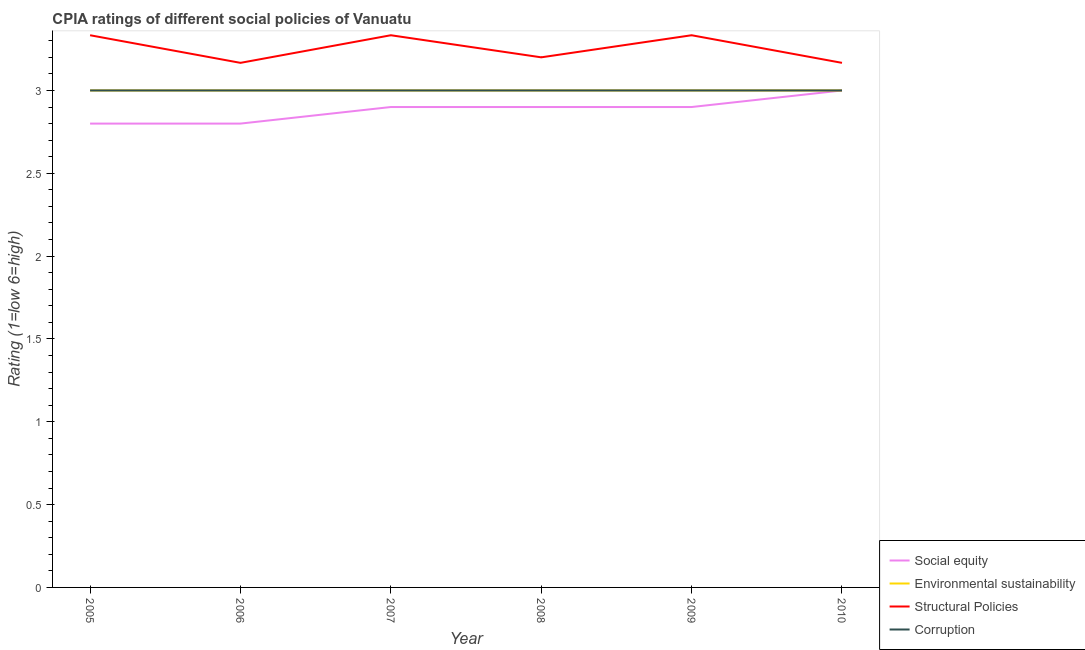Is the number of lines equal to the number of legend labels?
Offer a very short reply. Yes. What is the cpia rating of structural policies in 2010?
Provide a succinct answer. 3.17. Across all years, what is the maximum cpia rating of structural policies?
Your answer should be compact. 3.33. Across all years, what is the minimum cpia rating of corruption?
Your answer should be very brief. 3. In which year was the cpia rating of structural policies minimum?
Keep it short and to the point. 2006. What is the total cpia rating of corruption in the graph?
Offer a terse response. 18. What is the difference between the cpia rating of structural policies in 2008 and that in 2010?
Make the answer very short. 0.03. What is the difference between the cpia rating of social equity in 2009 and the cpia rating of structural policies in 2010?
Provide a succinct answer. -0.27. What is the average cpia rating of social equity per year?
Provide a succinct answer. 2.88. Is the difference between the cpia rating of corruption in 2007 and 2009 greater than the difference between the cpia rating of structural policies in 2007 and 2009?
Offer a terse response. No. What is the difference between the highest and the second highest cpia rating of structural policies?
Your response must be concise. 0. What is the difference between the highest and the lowest cpia rating of corruption?
Offer a terse response. 0. In how many years, is the cpia rating of social equity greater than the average cpia rating of social equity taken over all years?
Ensure brevity in your answer.  4. Is it the case that in every year, the sum of the cpia rating of environmental sustainability and cpia rating of corruption is greater than the sum of cpia rating of structural policies and cpia rating of social equity?
Keep it short and to the point. No. Is the cpia rating of corruption strictly greater than the cpia rating of environmental sustainability over the years?
Offer a very short reply. No. Is the cpia rating of environmental sustainability strictly less than the cpia rating of social equity over the years?
Offer a terse response. No. How many lines are there?
Ensure brevity in your answer.  4. Are the values on the major ticks of Y-axis written in scientific E-notation?
Ensure brevity in your answer.  No. Does the graph contain any zero values?
Make the answer very short. No. Does the graph contain grids?
Offer a very short reply. No. How many legend labels are there?
Keep it short and to the point. 4. How are the legend labels stacked?
Your answer should be very brief. Vertical. What is the title of the graph?
Make the answer very short. CPIA ratings of different social policies of Vanuatu. What is the label or title of the X-axis?
Offer a terse response. Year. What is the label or title of the Y-axis?
Make the answer very short. Rating (1=low 6=high). What is the Rating (1=low 6=high) in Social equity in 2005?
Offer a very short reply. 2.8. What is the Rating (1=low 6=high) of Structural Policies in 2005?
Provide a short and direct response. 3.33. What is the Rating (1=low 6=high) in Social equity in 2006?
Your response must be concise. 2.8. What is the Rating (1=low 6=high) in Environmental sustainability in 2006?
Give a very brief answer. 3. What is the Rating (1=low 6=high) of Structural Policies in 2006?
Ensure brevity in your answer.  3.17. What is the Rating (1=low 6=high) of Corruption in 2006?
Your answer should be very brief. 3. What is the Rating (1=low 6=high) of Environmental sustainability in 2007?
Make the answer very short. 3. What is the Rating (1=low 6=high) in Structural Policies in 2007?
Keep it short and to the point. 3.33. What is the Rating (1=low 6=high) of Corruption in 2007?
Your response must be concise. 3. What is the Rating (1=low 6=high) of Social equity in 2008?
Make the answer very short. 2.9. What is the Rating (1=low 6=high) in Environmental sustainability in 2008?
Your answer should be compact. 3. What is the Rating (1=low 6=high) in Corruption in 2008?
Provide a succinct answer. 3. What is the Rating (1=low 6=high) of Social equity in 2009?
Your answer should be very brief. 2.9. What is the Rating (1=low 6=high) of Environmental sustainability in 2009?
Provide a short and direct response. 3. What is the Rating (1=low 6=high) in Structural Policies in 2009?
Keep it short and to the point. 3.33. What is the Rating (1=low 6=high) of Corruption in 2009?
Ensure brevity in your answer.  3. What is the Rating (1=low 6=high) of Structural Policies in 2010?
Make the answer very short. 3.17. Across all years, what is the maximum Rating (1=low 6=high) of Social equity?
Make the answer very short. 3. Across all years, what is the maximum Rating (1=low 6=high) in Environmental sustainability?
Give a very brief answer. 3. Across all years, what is the maximum Rating (1=low 6=high) of Structural Policies?
Your response must be concise. 3.33. Across all years, what is the minimum Rating (1=low 6=high) of Structural Policies?
Your answer should be compact. 3.17. What is the total Rating (1=low 6=high) in Social equity in the graph?
Your answer should be very brief. 17.3. What is the total Rating (1=low 6=high) of Environmental sustainability in the graph?
Your answer should be very brief. 18. What is the total Rating (1=low 6=high) in Structural Policies in the graph?
Offer a terse response. 19.53. What is the difference between the Rating (1=low 6=high) in Social equity in 2005 and that in 2006?
Keep it short and to the point. 0. What is the difference between the Rating (1=low 6=high) in Environmental sustainability in 2005 and that in 2007?
Offer a terse response. 0. What is the difference between the Rating (1=low 6=high) of Structural Policies in 2005 and that in 2007?
Provide a succinct answer. 0. What is the difference between the Rating (1=low 6=high) of Environmental sustainability in 2005 and that in 2008?
Provide a succinct answer. 0. What is the difference between the Rating (1=low 6=high) of Structural Policies in 2005 and that in 2008?
Your response must be concise. 0.13. What is the difference between the Rating (1=low 6=high) in Environmental sustainability in 2005 and that in 2009?
Give a very brief answer. 0. What is the difference between the Rating (1=low 6=high) in Social equity in 2005 and that in 2010?
Ensure brevity in your answer.  -0.2. What is the difference between the Rating (1=low 6=high) of Environmental sustainability in 2005 and that in 2010?
Make the answer very short. 0. What is the difference between the Rating (1=low 6=high) of Corruption in 2005 and that in 2010?
Your answer should be compact. 0. What is the difference between the Rating (1=low 6=high) in Social equity in 2006 and that in 2008?
Offer a very short reply. -0.1. What is the difference between the Rating (1=low 6=high) in Structural Policies in 2006 and that in 2008?
Keep it short and to the point. -0.03. What is the difference between the Rating (1=low 6=high) of Social equity in 2006 and that in 2009?
Your answer should be compact. -0.1. What is the difference between the Rating (1=low 6=high) of Corruption in 2006 and that in 2009?
Provide a short and direct response. 0. What is the difference between the Rating (1=low 6=high) of Environmental sustainability in 2006 and that in 2010?
Make the answer very short. 0. What is the difference between the Rating (1=low 6=high) of Structural Policies in 2006 and that in 2010?
Offer a terse response. 0. What is the difference between the Rating (1=low 6=high) of Social equity in 2007 and that in 2008?
Ensure brevity in your answer.  0. What is the difference between the Rating (1=low 6=high) of Environmental sustainability in 2007 and that in 2008?
Your answer should be very brief. 0. What is the difference between the Rating (1=low 6=high) of Structural Policies in 2007 and that in 2008?
Provide a succinct answer. 0.13. What is the difference between the Rating (1=low 6=high) of Corruption in 2007 and that in 2008?
Offer a very short reply. 0. What is the difference between the Rating (1=low 6=high) in Social equity in 2007 and that in 2009?
Ensure brevity in your answer.  0. What is the difference between the Rating (1=low 6=high) in Structural Policies in 2007 and that in 2009?
Your answer should be compact. 0. What is the difference between the Rating (1=low 6=high) in Social equity in 2007 and that in 2010?
Your answer should be very brief. -0.1. What is the difference between the Rating (1=low 6=high) in Environmental sustainability in 2007 and that in 2010?
Provide a succinct answer. 0. What is the difference between the Rating (1=low 6=high) of Social equity in 2008 and that in 2009?
Keep it short and to the point. 0. What is the difference between the Rating (1=low 6=high) in Structural Policies in 2008 and that in 2009?
Ensure brevity in your answer.  -0.13. What is the difference between the Rating (1=low 6=high) of Social equity in 2008 and that in 2010?
Keep it short and to the point. -0.1. What is the difference between the Rating (1=low 6=high) of Corruption in 2008 and that in 2010?
Give a very brief answer. 0. What is the difference between the Rating (1=low 6=high) in Social equity in 2009 and that in 2010?
Offer a very short reply. -0.1. What is the difference between the Rating (1=low 6=high) of Environmental sustainability in 2009 and that in 2010?
Offer a very short reply. 0. What is the difference between the Rating (1=low 6=high) of Corruption in 2009 and that in 2010?
Offer a very short reply. 0. What is the difference between the Rating (1=low 6=high) of Social equity in 2005 and the Rating (1=low 6=high) of Environmental sustainability in 2006?
Your answer should be compact. -0.2. What is the difference between the Rating (1=low 6=high) in Social equity in 2005 and the Rating (1=low 6=high) in Structural Policies in 2006?
Offer a terse response. -0.37. What is the difference between the Rating (1=low 6=high) in Social equity in 2005 and the Rating (1=low 6=high) in Corruption in 2006?
Ensure brevity in your answer.  -0.2. What is the difference between the Rating (1=low 6=high) of Environmental sustainability in 2005 and the Rating (1=low 6=high) of Structural Policies in 2006?
Keep it short and to the point. -0.17. What is the difference between the Rating (1=low 6=high) in Environmental sustainability in 2005 and the Rating (1=low 6=high) in Corruption in 2006?
Your answer should be compact. 0. What is the difference between the Rating (1=low 6=high) of Structural Policies in 2005 and the Rating (1=low 6=high) of Corruption in 2006?
Your answer should be compact. 0.33. What is the difference between the Rating (1=low 6=high) of Social equity in 2005 and the Rating (1=low 6=high) of Environmental sustainability in 2007?
Give a very brief answer. -0.2. What is the difference between the Rating (1=low 6=high) in Social equity in 2005 and the Rating (1=low 6=high) in Structural Policies in 2007?
Give a very brief answer. -0.53. What is the difference between the Rating (1=low 6=high) in Social equity in 2005 and the Rating (1=low 6=high) in Corruption in 2007?
Your answer should be compact. -0.2. What is the difference between the Rating (1=low 6=high) of Environmental sustainability in 2005 and the Rating (1=low 6=high) of Structural Policies in 2007?
Ensure brevity in your answer.  -0.33. What is the difference between the Rating (1=low 6=high) of Structural Policies in 2005 and the Rating (1=low 6=high) of Corruption in 2007?
Your response must be concise. 0.33. What is the difference between the Rating (1=low 6=high) in Social equity in 2005 and the Rating (1=low 6=high) in Environmental sustainability in 2008?
Make the answer very short. -0.2. What is the difference between the Rating (1=low 6=high) of Environmental sustainability in 2005 and the Rating (1=low 6=high) of Corruption in 2008?
Your answer should be compact. 0. What is the difference between the Rating (1=low 6=high) in Social equity in 2005 and the Rating (1=low 6=high) in Environmental sustainability in 2009?
Make the answer very short. -0.2. What is the difference between the Rating (1=low 6=high) of Social equity in 2005 and the Rating (1=low 6=high) of Structural Policies in 2009?
Keep it short and to the point. -0.53. What is the difference between the Rating (1=low 6=high) in Social equity in 2005 and the Rating (1=low 6=high) in Corruption in 2009?
Your answer should be very brief. -0.2. What is the difference between the Rating (1=low 6=high) in Social equity in 2005 and the Rating (1=low 6=high) in Structural Policies in 2010?
Keep it short and to the point. -0.37. What is the difference between the Rating (1=low 6=high) of Social equity in 2005 and the Rating (1=low 6=high) of Corruption in 2010?
Your answer should be very brief. -0.2. What is the difference between the Rating (1=low 6=high) in Environmental sustainability in 2005 and the Rating (1=low 6=high) in Structural Policies in 2010?
Keep it short and to the point. -0.17. What is the difference between the Rating (1=low 6=high) in Structural Policies in 2005 and the Rating (1=low 6=high) in Corruption in 2010?
Ensure brevity in your answer.  0.33. What is the difference between the Rating (1=low 6=high) of Social equity in 2006 and the Rating (1=low 6=high) of Environmental sustainability in 2007?
Your answer should be very brief. -0.2. What is the difference between the Rating (1=low 6=high) in Social equity in 2006 and the Rating (1=low 6=high) in Structural Policies in 2007?
Keep it short and to the point. -0.53. What is the difference between the Rating (1=low 6=high) of Environmental sustainability in 2006 and the Rating (1=low 6=high) of Structural Policies in 2007?
Make the answer very short. -0.33. What is the difference between the Rating (1=low 6=high) in Social equity in 2006 and the Rating (1=low 6=high) in Structural Policies in 2008?
Keep it short and to the point. -0.4. What is the difference between the Rating (1=low 6=high) of Social equity in 2006 and the Rating (1=low 6=high) of Corruption in 2008?
Provide a succinct answer. -0.2. What is the difference between the Rating (1=low 6=high) of Environmental sustainability in 2006 and the Rating (1=low 6=high) of Structural Policies in 2008?
Ensure brevity in your answer.  -0.2. What is the difference between the Rating (1=low 6=high) in Environmental sustainability in 2006 and the Rating (1=low 6=high) in Corruption in 2008?
Provide a short and direct response. 0. What is the difference between the Rating (1=low 6=high) in Structural Policies in 2006 and the Rating (1=low 6=high) in Corruption in 2008?
Your answer should be compact. 0.17. What is the difference between the Rating (1=low 6=high) in Social equity in 2006 and the Rating (1=low 6=high) in Environmental sustainability in 2009?
Your answer should be very brief. -0.2. What is the difference between the Rating (1=low 6=high) in Social equity in 2006 and the Rating (1=low 6=high) in Structural Policies in 2009?
Keep it short and to the point. -0.53. What is the difference between the Rating (1=low 6=high) in Social equity in 2006 and the Rating (1=low 6=high) in Corruption in 2009?
Offer a very short reply. -0.2. What is the difference between the Rating (1=low 6=high) of Environmental sustainability in 2006 and the Rating (1=low 6=high) of Corruption in 2009?
Offer a terse response. 0. What is the difference between the Rating (1=low 6=high) in Structural Policies in 2006 and the Rating (1=low 6=high) in Corruption in 2009?
Provide a short and direct response. 0.17. What is the difference between the Rating (1=low 6=high) of Social equity in 2006 and the Rating (1=low 6=high) of Structural Policies in 2010?
Your answer should be compact. -0.37. What is the difference between the Rating (1=low 6=high) in Social equity in 2006 and the Rating (1=low 6=high) in Corruption in 2010?
Ensure brevity in your answer.  -0.2. What is the difference between the Rating (1=low 6=high) of Environmental sustainability in 2006 and the Rating (1=low 6=high) of Structural Policies in 2010?
Provide a succinct answer. -0.17. What is the difference between the Rating (1=low 6=high) of Environmental sustainability in 2006 and the Rating (1=low 6=high) of Corruption in 2010?
Offer a very short reply. 0. What is the difference between the Rating (1=low 6=high) of Structural Policies in 2006 and the Rating (1=low 6=high) of Corruption in 2010?
Your response must be concise. 0.17. What is the difference between the Rating (1=low 6=high) of Social equity in 2007 and the Rating (1=low 6=high) of Structural Policies in 2008?
Provide a short and direct response. -0.3. What is the difference between the Rating (1=low 6=high) of Social equity in 2007 and the Rating (1=low 6=high) of Corruption in 2008?
Make the answer very short. -0.1. What is the difference between the Rating (1=low 6=high) of Environmental sustainability in 2007 and the Rating (1=low 6=high) of Structural Policies in 2008?
Give a very brief answer. -0.2. What is the difference between the Rating (1=low 6=high) in Structural Policies in 2007 and the Rating (1=low 6=high) in Corruption in 2008?
Your answer should be compact. 0.33. What is the difference between the Rating (1=low 6=high) in Social equity in 2007 and the Rating (1=low 6=high) in Structural Policies in 2009?
Ensure brevity in your answer.  -0.43. What is the difference between the Rating (1=low 6=high) in Social equity in 2007 and the Rating (1=low 6=high) in Corruption in 2009?
Give a very brief answer. -0.1. What is the difference between the Rating (1=low 6=high) in Structural Policies in 2007 and the Rating (1=low 6=high) in Corruption in 2009?
Ensure brevity in your answer.  0.33. What is the difference between the Rating (1=low 6=high) in Social equity in 2007 and the Rating (1=low 6=high) in Structural Policies in 2010?
Your answer should be very brief. -0.27. What is the difference between the Rating (1=low 6=high) in Social equity in 2007 and the Rating (1=low 6=high) in Corruption in 2010?
Offer a terse response. -0.1. What is the difference between the Rating (1=low 6=high) of Environmental sustainability in 2007 and the Rating (1=low 6=high) of Structural Policies in 2010?
Provide a succinct answer. -0.17. What is the difference between the Rating (1=low 6=high) of Environmental sustainability in 2007 and the Rating (1=low 6=high) of Corruption in 2010?
Provide a short and direct response. 0. What is the difference between the Rating (1=low 6=high) of Structural Policies in 2007 and the Rating (1=low 6=high) of Corruption in 2010?
Your answer should be compact. 0.33. What is the difference between the Rating (1=low 6=high) in Social equity in 2008 and the Rating (1=low 6=high) in Environmental sustainability in 2009?
Offer a terse response. -0.1. What is the difference between the Rating (1=low 6=high) in Social equity in 2008 and the Rating (1=low 6=high) in Structural Policies in 2009?
Give a very brief answer. -0.43. What is the difference between the Rating (1=low 6=high) of Social equity in 2008 and the Rating (1=low 6=high) of Corruption in 2009?
Make the answer very short. -0.1. What is the difference between the Rating (1=low 6=high) of Environmental sustainability in 2008 and the Rating (1=low 6=high) of Structural Policies in 2009?
Your response must be concise. -0.33. What is the difference between the Rating (1=low 6=high) in Structural Policies in 2008 and the Rating (1=low 6=high) in Corruption in 2009?
Ensure brevity in your answer.  0.2. What is the difference between the Rating (1=low 6=high) of Social equity in 2008 and the Rating (1=low 6=high) of Environmental sustainability in 2010?
Your answer should be very brief. -0.1. What is the difference between the Rating (1=low 6=high) in Social equity in 2008 and the Rating (1=low 6=high) in Structural Policies in 2010?
Provide a short and direct response. -0.27. What is the difference between the Rating (1=low 6=high) in Environmental sustainability in 2008 and the Rating (1=low 6=high) in Structural Policies in 2010?
Keep it short and to the point. -0.17. What is the difference between the Rating (1=low 6=high) of Structural Policies in 2008 and the Rating (1=low 6=high) of Corruption in 2010?
Your response must be concise. 0.2. What is the difference between the Rating (1=low 6=high) in Social equity in 2009 and the Rating (1=low 6=high) in Structural Policies in 2010?
Your answer should be very brief. -0.27. What is the difference between the Rating (1=low 6=high) of Environmental sustainability in 2009 and the Rating (1=low 6=high) of Corruption in 2010?
Your response must be concise. 0. What is the average Rating (1=low 6=high) in Social equity per year?
Provide a succinct answer. 2.88. What is the average Rating (1=low 6=high) in Environmental sustainability per year?
Your answer should be compact. 3. What is the average Rating (1=low 6=high) of Structural Policies per year?
Keep it short and to the point. 3.26. In the year 2005, what is the difference between the Rating (1=low 6=high) in Social equity and Rating (1=low 6=high) in Structural Policies?
Provide a short and direct response. -0.53. In the year 2005, what is the difference between the Rating (1=low 6=high) in Environmental sustainability and Rating (1=low 6=high) in Structural Policies?
Offer a very short reply. -0.33. In the year 2005, what is the difference between the Rating (1=low 6=high) of Environmental sustainability and Rating (1=low 6=high) of Corruption?
Make the answer very short. 0. In the year 2006, what is the difference between the Rating (1=low 6=high) of Social equity and Rating (1=low 6=high) of Structural Policies?
Your response must be concise. -0.37. In the year 2006, what is the difference between the Rating (1=low 6=high) of Environmental sustainability and Rating (1=low 6=high) of Structural Policies?
Ensure brevity in your answer.  -0.17. In the year 2007, what is the difference between the Rating (1=low 6=high) in Social equity and Rating (1=low 6=high) in Structural Policies?
Give a very brief answer. -0.43. In the year 2007, what is the difference between the Rating (1=low 6=high) in Social equity and Rating (1=low 6=high) in Corruption?
Offer a very short reply. -0.1. In the year 2007, what is the difference between the Rating (1=low 6=high) of Environmental sustainability and Rating (1=low 6=high) of Structural Policies?
Make the answer very short. -0.33. In the year 2007, what is the difference between the Rating (1=low 6=high) in Structural Policies and Rating (1=low 6=high) in Corruption?
Provide a succinct answer. 0.33. In the year 2008, what is the difference between the Rating (1=low 6=high) of Social equity and Rating (1=low 6=high) of Environmental sustainability?
Offer a terse response. -0.1. In the year 2008, what is the difference between the Rating (1=low 6=high) in Environmental sustainability and Rating (1=low 6=high) in Structural Policies?
Your answer should be compact. -0.2. In the year 2008, what is the difference between the Rating (1=low 6=high) in Structural Policies and Rating (1=low 6=high) in Corruption?
Keep it short and to the point. 0.2. In the year 2009, what is the difference between the Rating (1=low 6=high) of Social equity and Rating (1=low 6=high) of Structural Policies?
Your response must be concise. -0.43. In the year 2009, what is the difference between the Rating (1=low 6=high) of Environmental sustainability and Rating (1=low 6=high) of Structural Policies?
Offer a very short reply. -0.33. In the year 2009, what is the difference between the Rating (1=low 6=high) in Environmental sustainability and Rating (1=low 6=high) in Corruption?
Keep it short and to the point. 0. In the year 2010, what is the difference between the Rating (1=low 6=high) in Social equity and Rating (1=low 6=high) in Environmental sustainability?
Provide a short and direct response. 0. In the year 2010, what is the difference between the Rating (1=low 6=high) in Social equity and Rating (1=low 6=high) in Structural Policies?
Keep it short and to the point. -0.17. In the year 2010, what is the difference between the Rating (1=low 6=high) of Social equity and Rating (1=low 6=high) of Corruption?
Provide a short and direct response. 0. In the year 2010, what is the difference between the Rating (1=low 6=high) in Environmental sustainability and Rating (1=low 6=high) in Structural Policies?
Provide a succinct answer. -0.17. What is the ratio of the Rating (1=low 6=high) of Structural Policies in 2005 to that in 2006?
Your answer should be compact. 1.05. What is the ratio of the Rating (1=low 6=high) of Social equity in 2005 to that in 2007?
Your response must be concise. 0.97. What is the ratio of the Rating (1=low 6=high) of Environmental sustainability in 2005 to that in 2007?
Make the answer very short. 1. What is the ratio of the Rating (1=low 6=high) in Corruption in 2005 to that in 2007?
Make the answer very short. 1. What is the ratio of the Rating (1=low 6=high) in Social equity in 2005 to that in 2008?
Your answer should be compact. 0.97. What is the ratio of the Rating (1=low 6=high) of Structural Policies in 2005 to that in 2008?
Ensure brevity in your answer.  1.04. What is the ratio of the Rating (1=low 6=high) in Corruption in 2005 to that in 2008?
Your answer should be very brief. 1. What is the ratio of the Rating (1=low 6=high) in Social equity in 2005 to that in 2009?
Your answer should be very brief. 0.97. What is the ratio of the Rating (1=low 6=high) of Environmental sustainability in 2005 to that in 2009?
Provide a succinct answer. 1. What is the ratio of the Rating (1=low 6=high) of Structural Policies in 2005 to that in 2009?
Provide a succinct answer. 1. What is the ratio of the Rating (1=low 6=high) of Corruption in 2005 to that in 2009?
Your answer should be very brief. 1. What is the ratio of the Rating (1=low 6=high) of Environmental sustainability in 2005 to that in 2010?
Provide a short and direct response. 1. What is the ratio of the Rating (1=low 6=high) in Structural Policies in 2005 to that in 2010?
Make the answer very short. 1.05. What is the ratio of the Rating (1=low 6=high) in Social equity in 2006 to that in 2007?
Ensure brevity in your answer.  0.97. What is the ratio of the Rating (1=low 6=high) of Environmental sustainability in 2006 to that in 2007?
Make the answer very short. 1. What is the ratio of the Rating (1=low 6=high) of Structural Policies in 2006 to that in 2007?
Keep it short and to the point. 0.95. What is the ratio of the Rating (1=low 6=high) in Corruption in 2006 to that in 2007?
Make the answer very short. 1. What is the ratio of the Rating (1=low 6=high) of Social equity in 2006 to that in 2008?
Make the answer very short. 0.97. What is the ratio of the Rating (1=low 6=high) in Environmental sustainability in 2006 to that in 2008?
Offer a very short reply. 1. What is the ratio of the Rating (1=low 6=high) in Corruption in 2006 to that in 2008?
Give a very brief answer. 1. What is the ratio of the Rating (1=low 6=high) in Social equity in 2006 to that in 2009?
Keep it short and to the point. 0.97. What is the ratio of the Rating (1=low 6=high) in Corruption in 2006 to that in 2009?
Your answer should be very brief. 1. What is the ratio of the Rating (1=low 6=high) in Environmental sustainability in 2006 to that in 2010?
Your answer should be compact. 1. What is the ratio of the Rating (1=low 6=high) of Structural Policies in 2006 to that in 2010?
Give a very brief answer. 1. What is the ratio of the Rating (1=low 6=high) in Corruption in 2006 to that in 2010?
Provide a succinct answer. 1. What is the ratio of the Rating (1=low 6=high) in Structural Policies in 2007 to that in 2008?
Ensure brevity in your answer.  1.04. What is the ratio of the Rating (1=low 6=high) of Social equity in 2007 to that in 2009?
Your answer should be compact. 1. What is the ratio of the Rating (1=low 6=high) in Social equity in 2007 to that in 2010?
Give a very brief answer. 0.97. What is the ratio of the Rating (1=low 6=high) in Structural Policies in 2007 to that in 2010?
Ensure brevity in your answer.  1.05. What is the ratio of the Rating (1=low 6=high) in Corruption in 2007 to that in 2010?
Provide a succinct answer. 1. What is the ratio of the Rating (1=low 6=high) in Social equity in 2008 to that in 2009?
Give a very brief answer. 1. What is the ratio of the Rating (1=low 6=high) in Structural Policies in 2008 to that in 2009?
Provide a succinct answer. 0.96. What is the ratio of the Rating (1=low 6=high) in Social equity in 2008 to that in 2010?
Your response must be concise. 0.97. What is the ratio of the Rating (1=low 6=high) in Environmental sustainability in 2008 to that in 2010?
Ensure brevity in your answer.  1. What is the ratio of the Rating (1=low 6=high) of Structural Policies in 2008 to that in 2010?
Give a very brief answer. 1.01. What is the ratio of the Rating (1=low 6=high) of Corruption in 2008 to that in 2010?
Your answer should be very brief. 1. What is the ratio of the Rating (1=low 6=high) of Social equity in 2009 to that in 2010?
Provide a short and direct response. 0.97. What is the ratio of the Rating (1=low 6=high) of Environmental sustainability in 2009 to that in 2010?
Make the answer very short. 1. What is the ratio of the Rating (1=low 6=high) in Structural Policies in 2009 to that in 2010?
Provide a short and direct response. 1.05. What is the difference between the highest and the second highest Rating (1=low 6=high) of Environmental sustainability?
Ensure brevity in your answer.  0. What is the difference between the highest and the second highest Rating (1=low 6=high) of Corruption?
Ensure brevity in your answer.  0. What is the difference between the highest and the lowest Rating (1=low 6=high) in Social equity?
Ensure brevity in your answer.  0.2. What is the difference between the highest and the lowest Rating (1=low 6=high) in Environmental sustainability?
Provide a short and direct response. 0. What is the difference between the highest and the lowest Rating (1=low 6=high) in Structural Policies?
Provide a succinct answer. 0.17. 